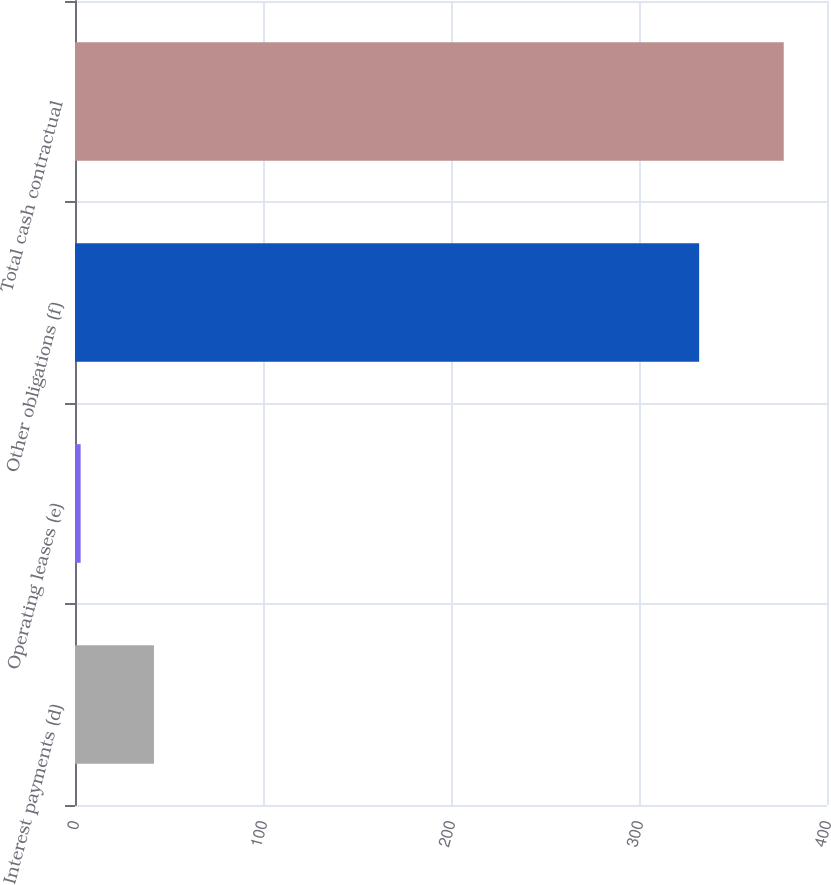Convert chart. <chart><loc_0><loc_0><loc_500><loc_500><bar_chart><fcel>Interest payments (d)<fcel>Operating leases (e)<fcel>Other obligations (f)<fcel>Total cash contractual<nl><fcel>42<fcel>3<fcel>332<fcel>377<nl></chart> 